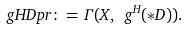Convert formula to latex. <formula><loc_0><loc_0><loc_500><loc_500>\ g H D p r \colon = \Gamma ( X , \ g ^ { H } ( \ast D ) ) .</formula> 